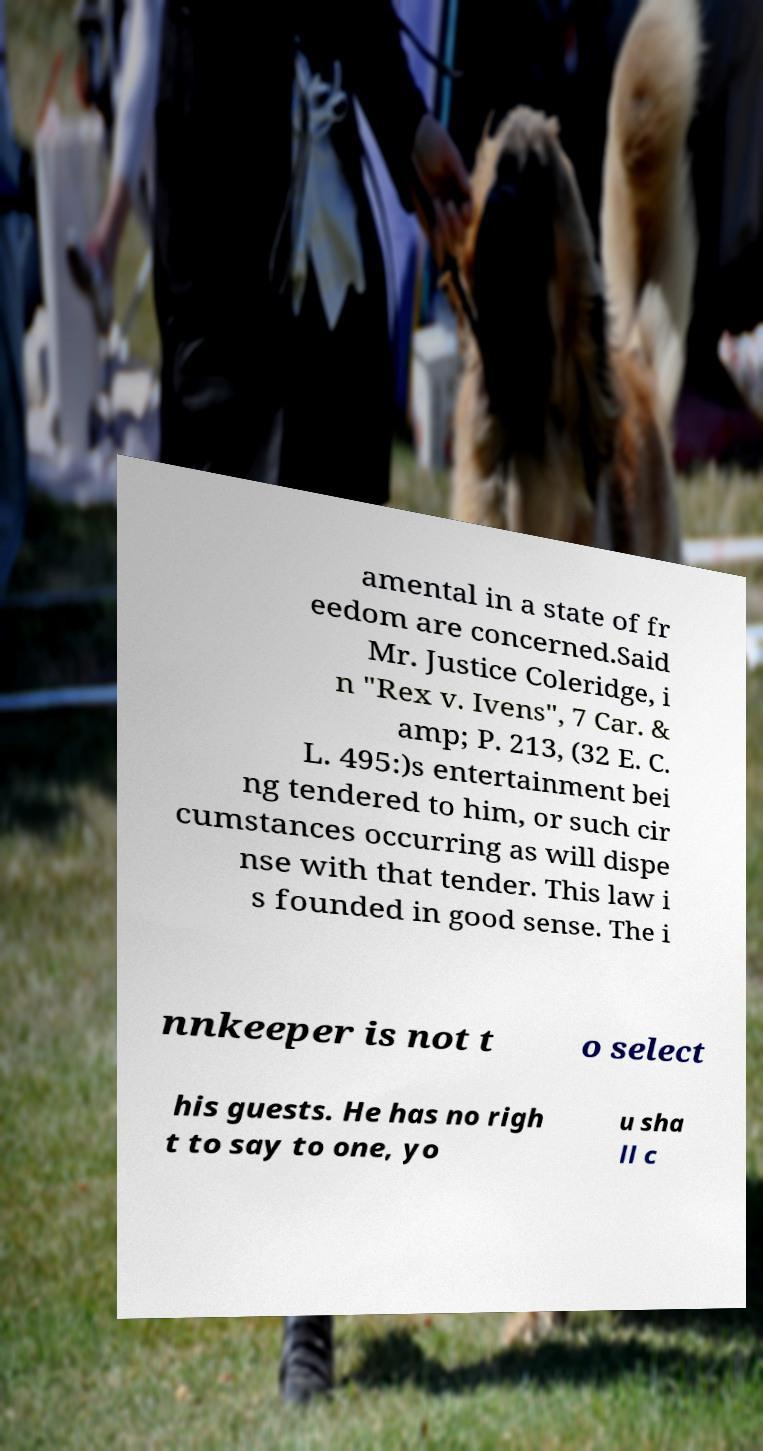Could you extract and type out the text from this image? amental in a state of fr eedom are concerned.Said Mr. Justice Coleridge, i n "Rex v. Ivens", 7 Car. & amp; P. 213, (32 E. C. L. 495:)s entertainment bei ng tendered to him, or such cir cumstances occurring as will dispe nse with that tender. This law i s founded in good sense. The i nnkeeper is not t o select his guests. He has no righ t to say to one, yo u sha ll c 